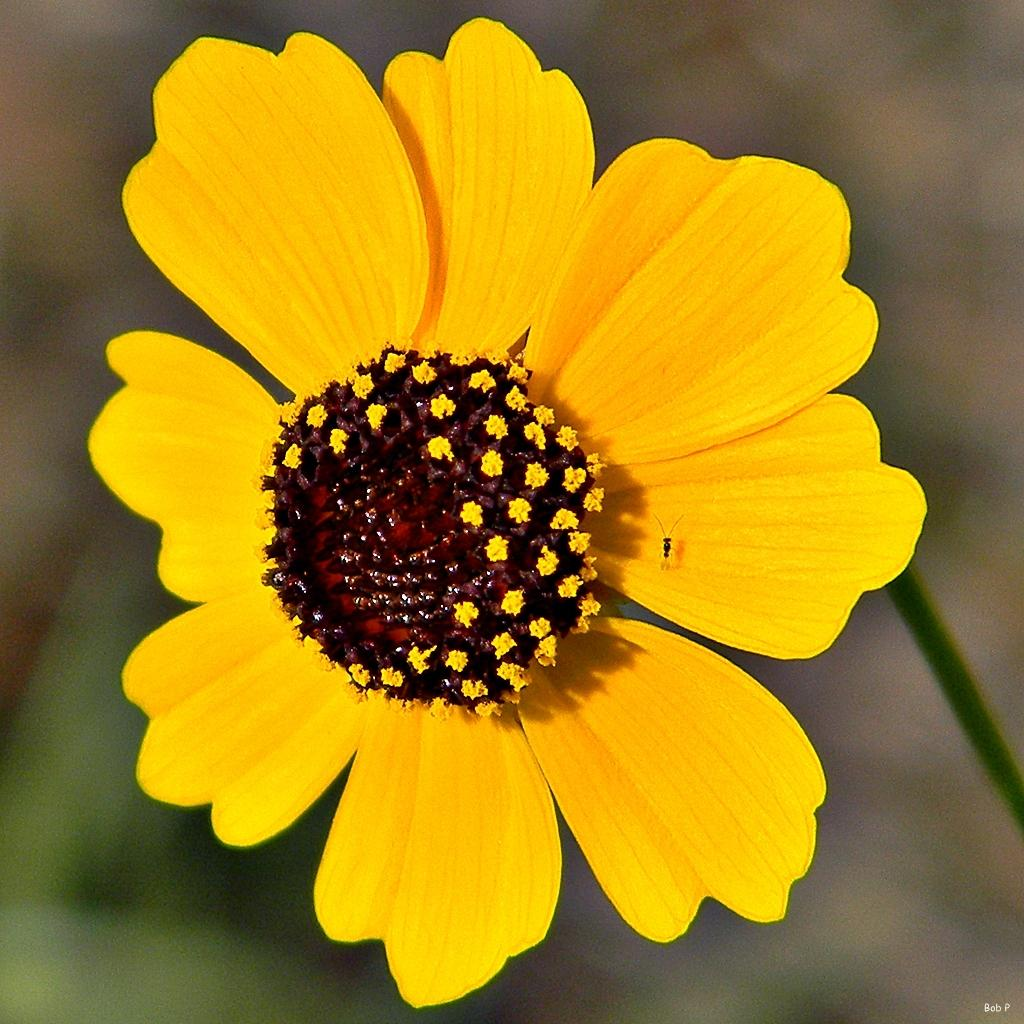What is the main subject of the image? There is a flower in the image. Are there any other living organisms present in the image? Yes, there is an insect is present in the image. Can you describe the background of the image? The background of the image is blurred. What type of engine can be seen powering the flower in the image? There is no engine present in the image, and the flower is not powered by any engine. 